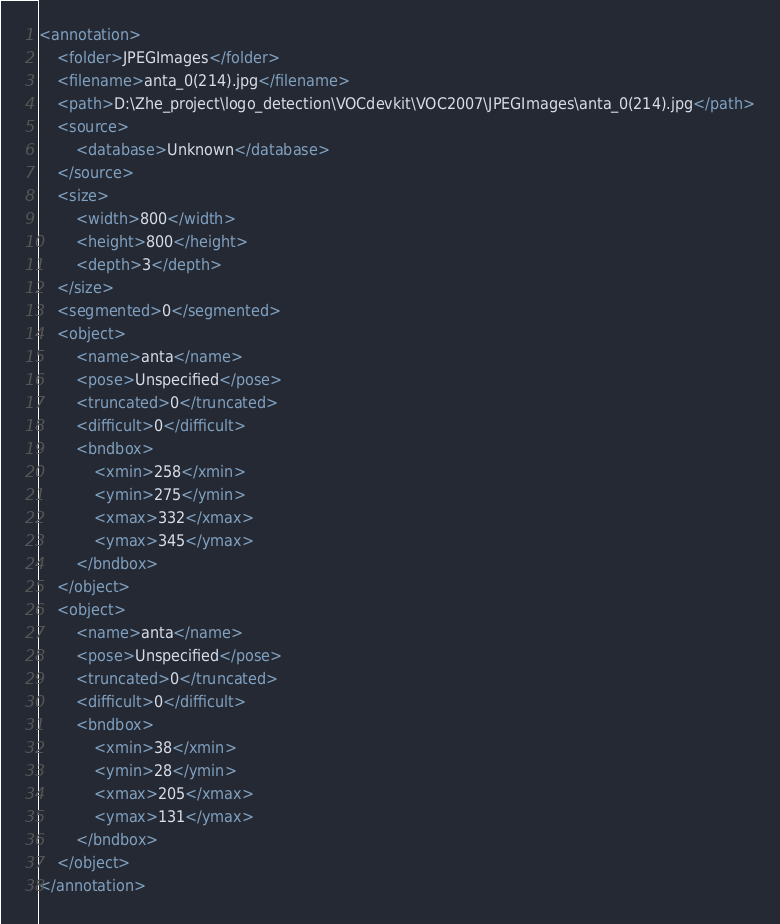<code> <loc_0><loc_0><loc_500><loc_500><_XML_><annotation>
	<folder>JPEGImages</folder>
	<filename>anta_0(214).jpg</filename>
	<path>D:\Zhe_project\logo_detection\VOCdevkit\VOC2007\JPEGImages\anta_0(214).jpg</path>
	<source>
		<database>Unknown</database>
	</source>
	<size>
		<width>800</width>
		<height>800</height>
		<depth>3</depth>
	</size>
	<segmented>0</segmented>
	<object>
		<name>anta</name>
		<pose>Unspecified</pose>
		<truncated>0</truncated>
		<difficult>0</difficult>
		<bndbox>
			<xmin>258</xmin>
			<ymin>275</ymin>
			<xmax>332</xmax>
			<ymax>345</ymax>
		</bndbox>
	</object>
	<object>
		<name>anta</name>
		<pose>Unspecified</pose>
		<truncated>0</truncated>
		<difficult>0</difficult>
		<bndbox>
			<xmin>38</xmin>
			<ymin>28</ymin>
			<xmax>205</xmax>
			<ymax>131</ymax>
		</bndbox>
	</object>
</annotation>
</code> 